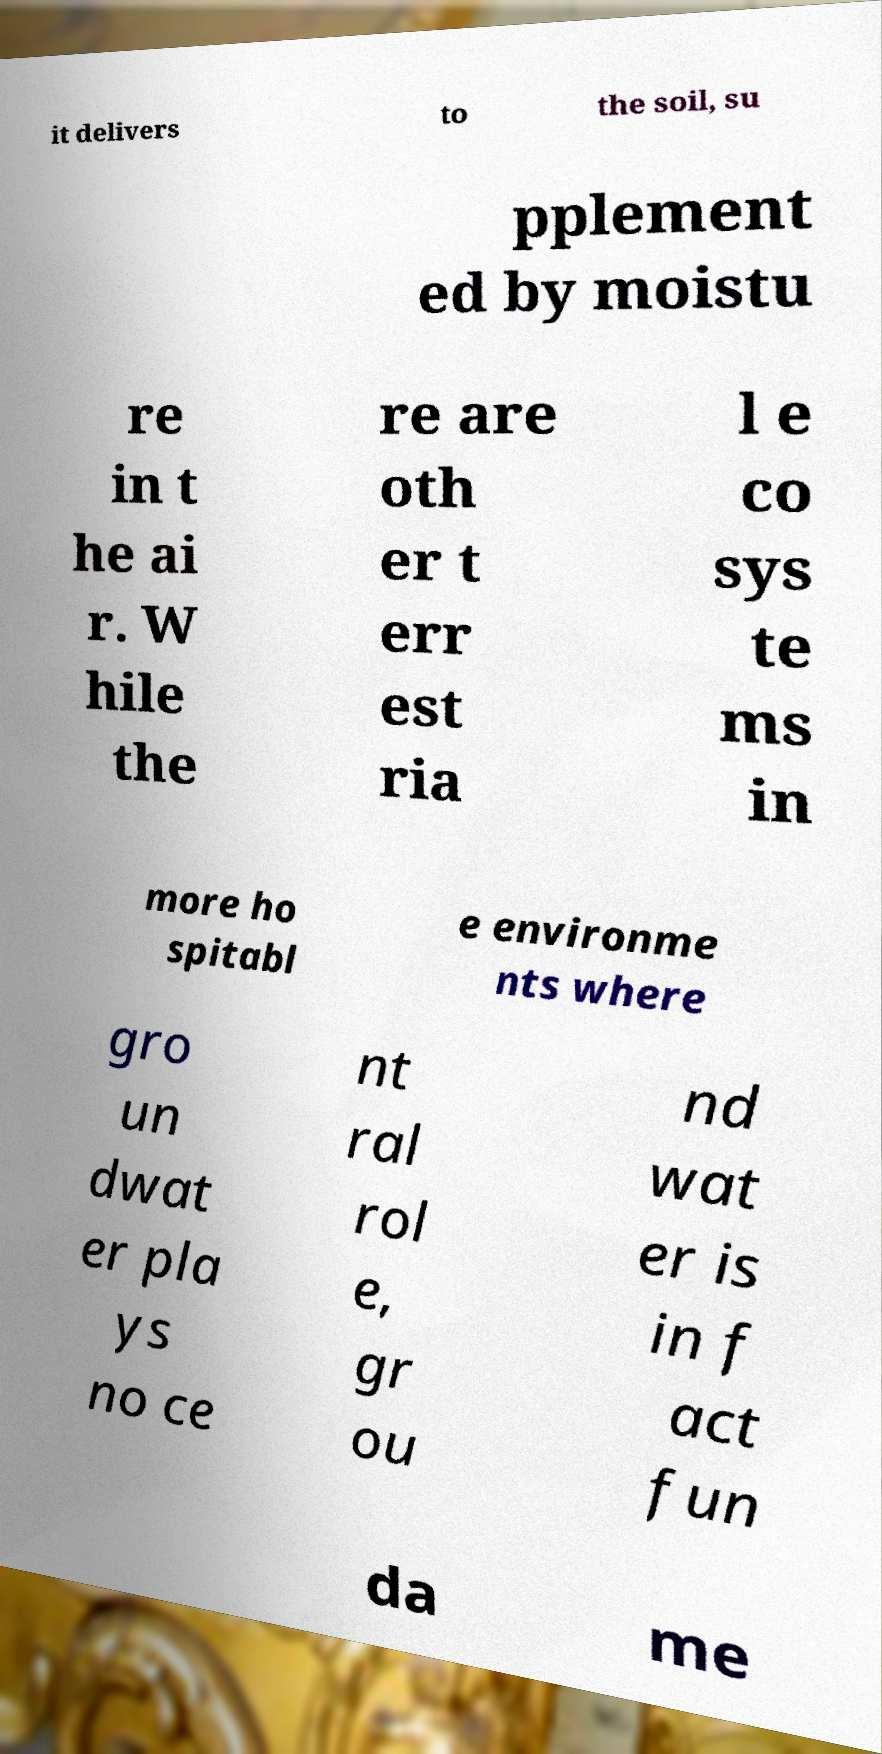For documentation purposes, I need the text within this image transcribed. Could you provide that? it delivers to the soil, su pplement ed by moistu re in t he ai r. W hile the re are oth er t err est ria l e co sys te ms in more ho spitabl e environme nts where gro un dwat er pla ys no ce nt ral rol e, gr ou nd wat er is in f act fun da me 